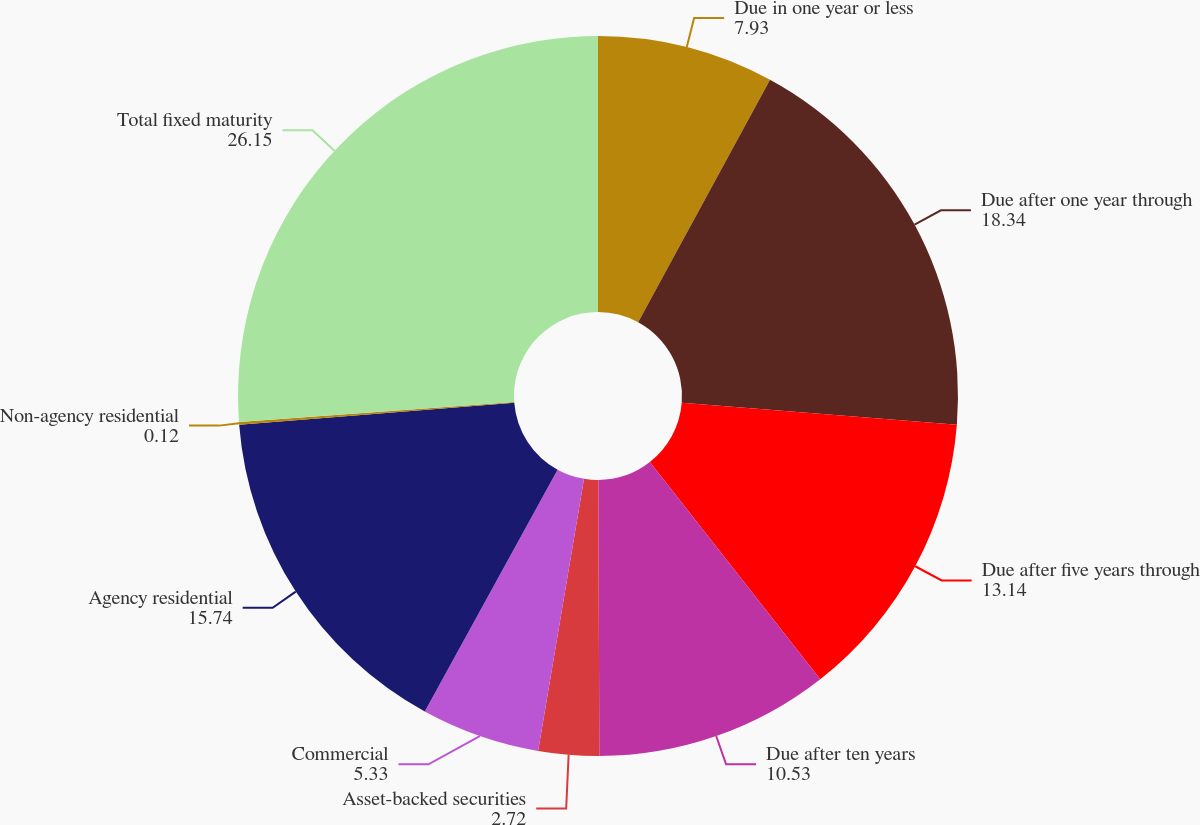Convert chart. <chart><loc_0><loc_0><loc_500><loc_500><pie_chart><fcel>Due in one year or less<fcel>Due after one year through<fcel>Due after five years through<fcel>Due after ten years<fcel>Asset-backed securities<fcel>Commercial<fcel>Agency residential<fcel>Non-agency residential<fcel>Total fixed maturity<nl><fcel>7.93%<fcel>18.34%<fcel>13.14%<fcel>10.53%<fcel>2.72%<fcel>5.33%<fcel>15.74%<fcel>0.12%<fcel>26.15%<nl></chart> 